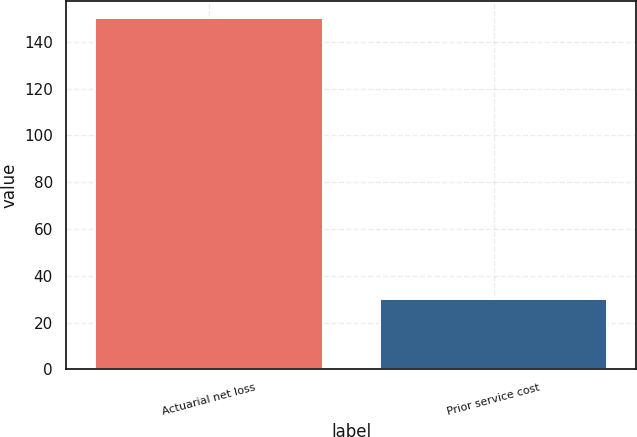Convert chart to OTSL. <chart><loc_0><loc_0><loc_500><loc_500><bar_chart><fcel>Actuarial net loss<fcel>Prior service cost<nl><fcel>150<fcel>30<nl></chart> 